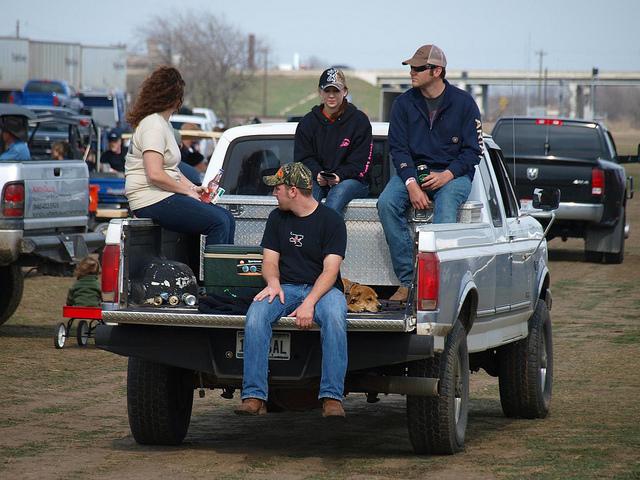How many different color stripes are on this truck?
Give a very brief answer. 1. Could this be a peaceful demonstration?
Give a very brief answer. Yes. How many dogs are in the picture?
Concise answer only. 1. Are the people sitting on the truck?
Write a very short answer. Yes. How many men in the truck in the back?
Quick response, please. 3. Can you tell what year it is by the clothing worn and the model of the vehicle?
Be succinct. No. Are they all wearing jeans?
Be succinct. Yes. Is there any women sitting on the back of the truck?
Give a very brief answer. Yes. 